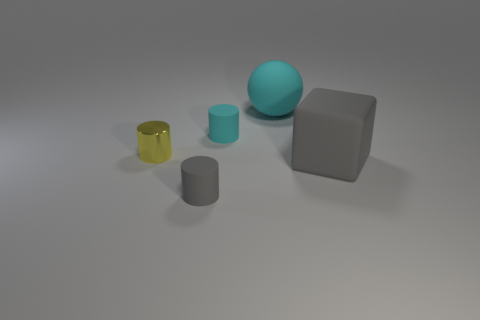Is there anything else that has the same material as the tiny yellow object?
Ensure brevity in your answer.  No. What is the material of the small cylinder that is the same color as the matte cube?
Offer a terse response. Rubber. There is another tiny matte object that is the same shape as the tiny gray object; what color is it?
Provide a succinct answer. Cyan. Is there any other thing that is the same shape as the large gray object?
Offer a terse response. No. There is a tiny object behind the yellow cylinder; is its shape the same as the gray object on the left side of the small cyan object?
Provide a short and direct response. Yes. There is a gray matte cylinder; is its size the same as the rubber sphere that is behind the small cyan cylinder?
Your response must be concise. No. Is the number of small red rubber blocks greater than the number of yellow shiny cylinders?
Offer a terse response. No. Do the tiny cylinder that is in front of the gray matte block and the small cylinder to the left of the gray rubber cylinder have the same material?
Keep it short and to the point. No. What is the large gray block made of?
Ensure brevity in your answer.  Rubber. Are there more rubber objects behind the gray matte cube than cyan shiny blocks?
Ensure brevity in your answer.  Yes. 